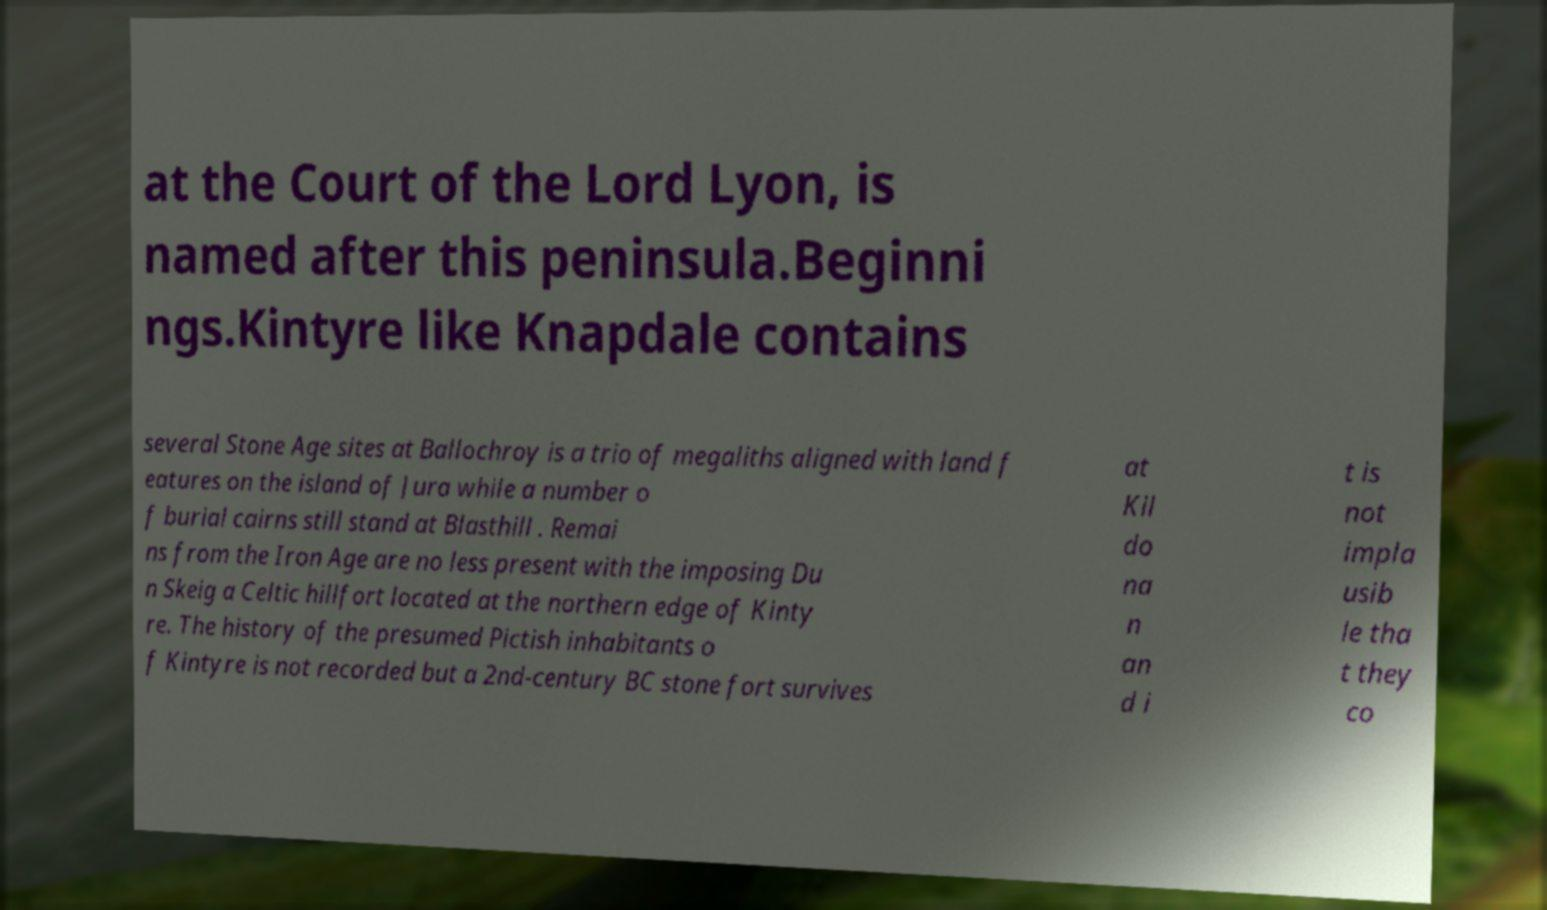Can you accurately transcribe the text from the provided image for me? at the Court of the Lord Lyon, is named after this peninsula.Beginni ngs.Kintyre like Knapdale contains several Stone Age sites at Ballochroy is a trio of megaliths aligned with land f eatures on the island of Jura while a number o f burial cairns still stand at Blasthill . Remai ns from the Iron Age are no less present with the imposing Du n Skeig a Celtic hillfort located at the northern edge of Kinty re. The history of the presumed Pictish inhabitants o f Kintyre is not recorded but a 2nd-century BC stone fort survives at Kil do na n an d i t is not impla usib le tha t they co 